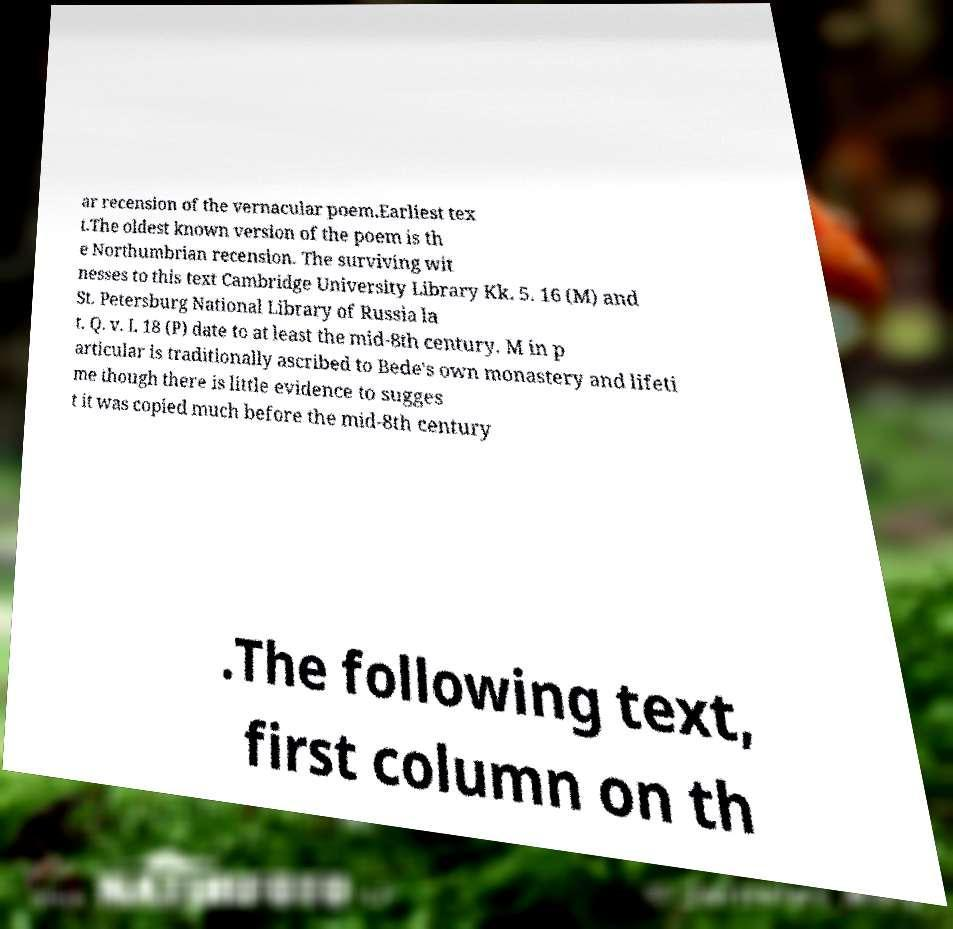What messages or text are displayed in this image? I need them in a readable, typed format. ar recension of the vernacular poem.Earliest tex t.The oldest known version of the poem is th e Northumbrian recension. The surviving wit nesses to this text Cambridge University Library Kk. 5. 16 (M) and St. Petersburg National Library of Russia la t. Q. v. I. 18 (P) date to at least the mid-8th century. M in p articular is traditionally ascribed to Bede's own monastery and lifeti me though there is little evidence to sugges t it was copied much before the mid-8th century .The following text, first column on th 